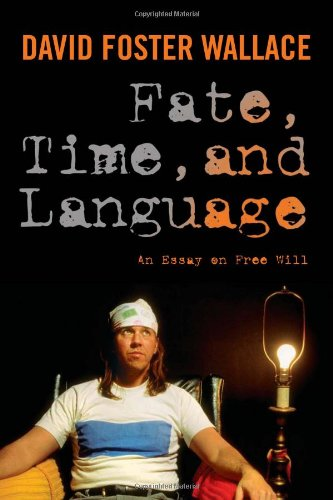What is the title of this book? The title of the book is 'Fate, Time, and Language: An Essay on Free Will,' which suggests a philosophical exploration into concepts of determinism and free will. 